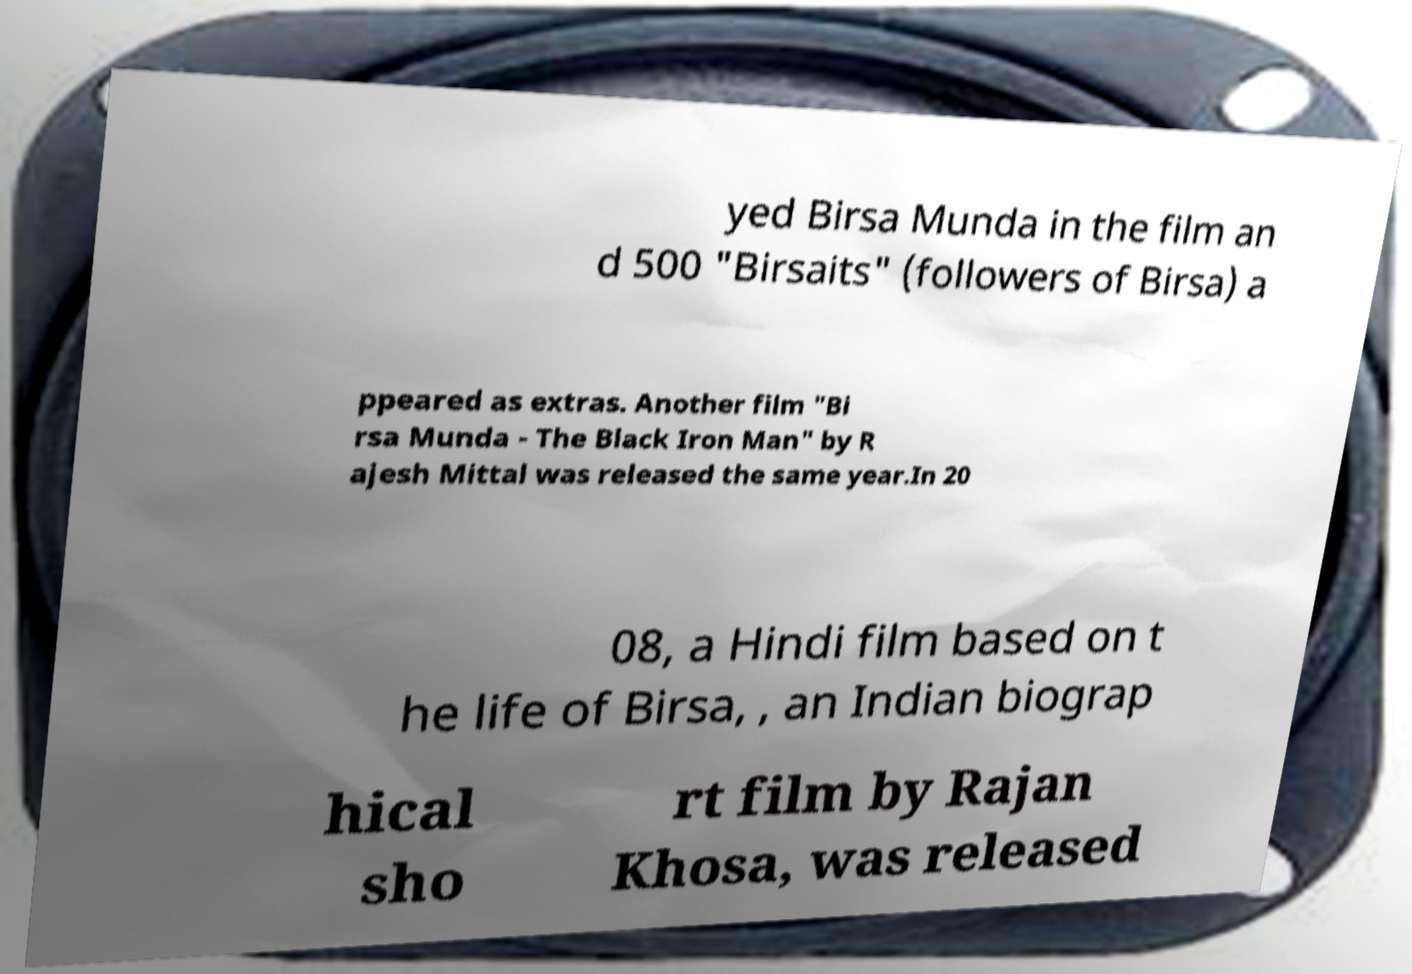Could you assist in decoding the text presented in this image and type it out clearly? yed Birsa Munda in the film an d 500 "Birsaits" (followers of Birsa) a ppeared as extras. Another film "Bi rsa Munda - The Black Iron Man" by R ajesh Mittal was released the same year.In 20 08, a Hindi film based on t he life of Birsa, , an Indian biograp hical sho rt film by Rajan Khosa, was released 